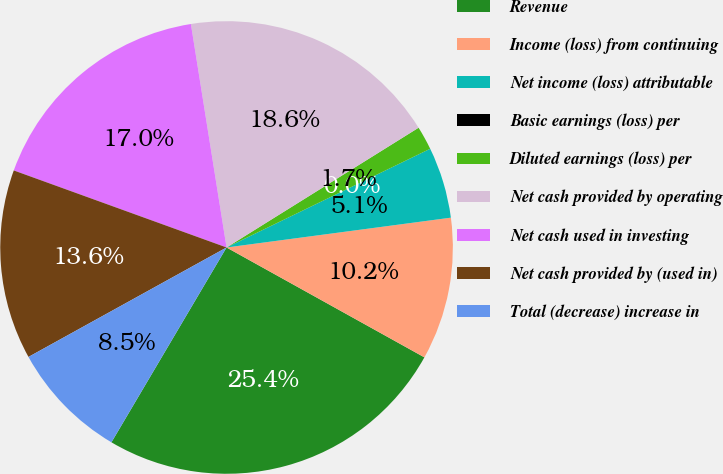Convert chart. <chart><loc_0><loc_0><loc_500><loc_500><pie_chart><fcel>Revenue<fcel>Income (loss) from continuing<fcel>Net income (loss) attributable<fcel>Basic earnings (loss) per<fcel>Diluted earnings (loss) per<fcel>Net cash provided by operating<fcel>Net cash used in investing<fcel>Net cash provided by (used in)<fcel>Total (decrease) increase in<nl><fcel>25.42%<fcel>10.17%<fcel>5.08%<fcel>0.0%<fcel>1.69%<fcel>18.64%<fcel>16.95%<fcel>13.56%<fcel>8.47%<nl></chart> 